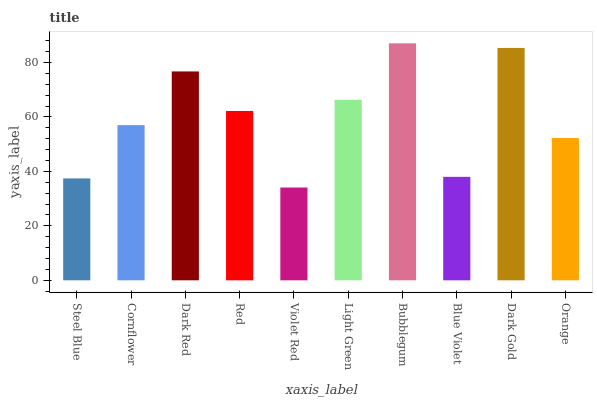Is Violet Red the minimum?
Answer yes or no. Yes. Is Bubblegum the maximum?
Answer yes or no. Yes. Is Cornflower the minimum?
Answer yes or no. No. Is Cornflower the maximum?
Answer yes or no. No. Is Cornflower greater than Steel Blue?
Answer yes or no. Yes. Is Steel Blue less than Cornflower?
Answer yes or no. Yes. Is Steel Blue greater than Cornflower?
Answer yes or no. No. Is Cornflower less than Steel Blue?
Answer yes or no. No. Is Red the high median?
Answer yes or no. Yes. Is Cornflower the low median?
Answer yes or no. Yes. Is Orange the high median?
Answer yes or no. No. Is Orange the low median?
Answer yes or no. No. 